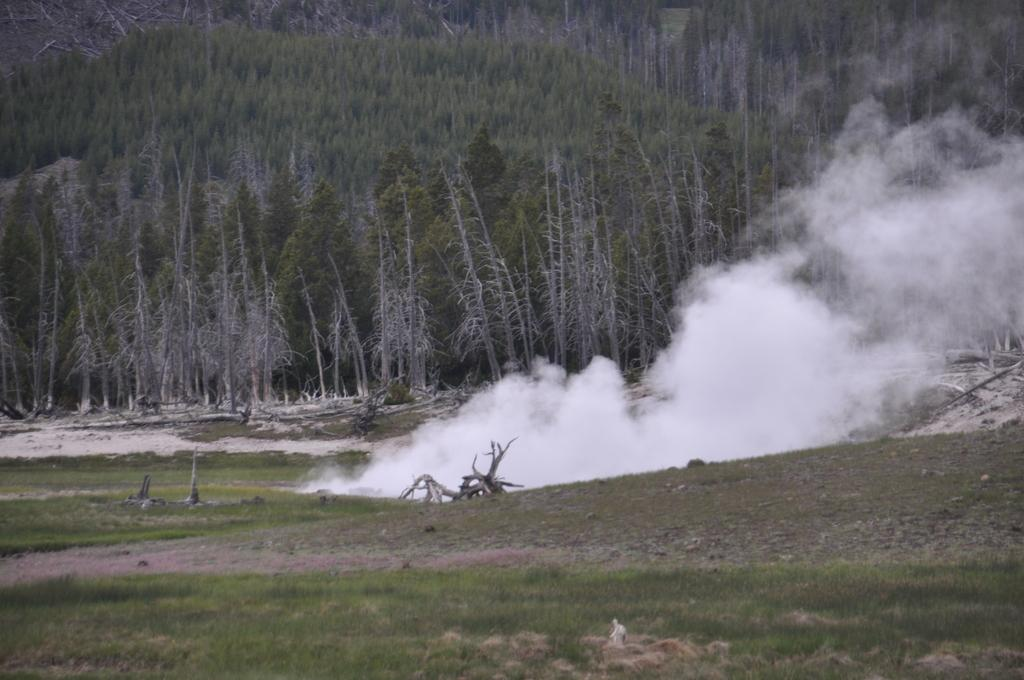Where was the image taken? The image was clicked outside. What type of ground is visible at the bottom of the image? There is grass at the bottom of the image. What can be seen in the middle of the image? There is white-colored smoke in the middle of the image. What is visible in the background of the image? There are many trees in the background of the image. What time of day is it in the image, according to the company's morning theory? There is no reference to a company or a morning theory in the image, so it is not possible to determine the time of day based on that information. 